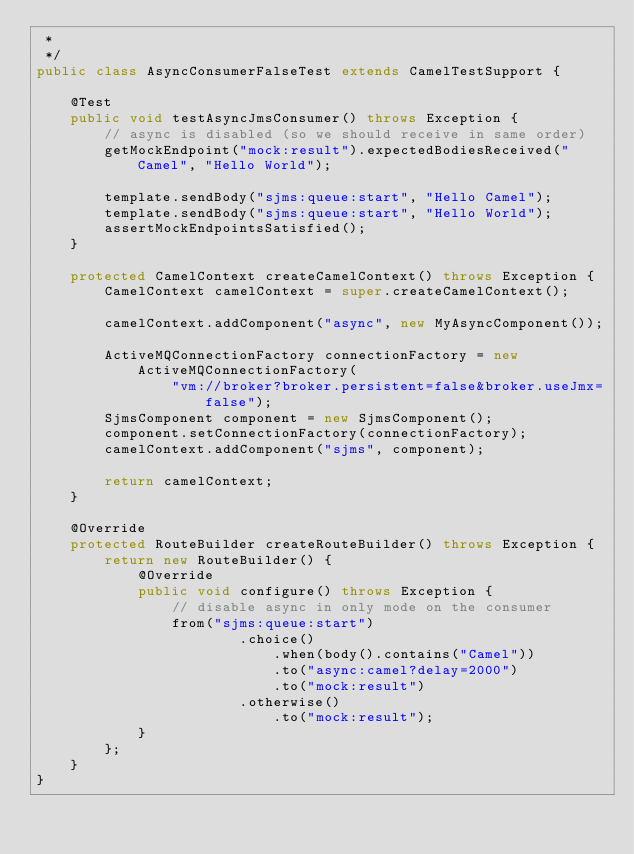<code> <loc_0><loc_0><loc_500><loc_500><_Java_> *
 */
public class AsyncConsumerFalseTest extends CamelTestSupport {

    @Test
    public void testAsyncJmsConsumer() throws Exception {
        // async is disabled (so we should receive in same order)
        getMockEndpoint("mock:result").expectedBodiesReceived("Camel", "Hello World");

        template.sendBody("sjms:queue:start", "Hello Camel");
        template.sendBody("sjms:queue:start", "Hello World");
        assertMockEndpointsSatisfied();
    }

    protected CamelContext createCamelContext() throws Exception {
        CamelContext camelContext = super.createCamelContext();

        camelContext.addComponent("async", new MyAsyncComponent());

        ActiveMQConnectionFactory connectionFactory = new ActiveMQConnectionFactory(
                "vm://broker?broker.persistent=false&broker.useJmx=false");
        SjmsComponent component = new SjmsComponent();
        component.setConnectionFactory(connectionFactory);
        camelContext.addComponent("sjms", component);

        return camelContext;
    }

    @Override
    protected RouteBuilder createRouteBuilder() throws Exception {
        return new RouteBuilder() {
            @Override
            public void configure() throws Exception {
                // disable async in only mode on the consumer
                from("sjms:queue:start")
                        .choice()
                            .when(body().contains("Camel"))
                            .to("async:camel?delay=2000")
                            .to("mock:result")
                        .otherwise()
                            .to("mock:result");
            }
        };
    }
}
</code> 